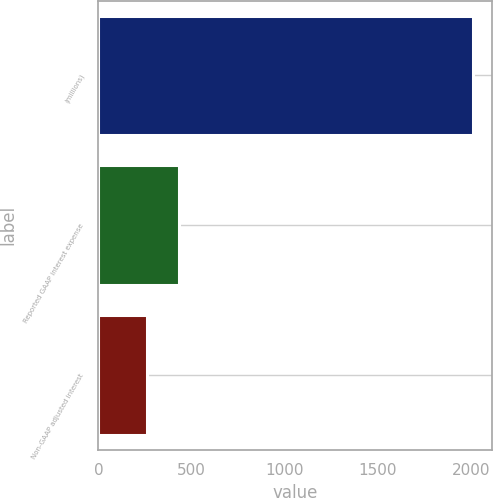Convert chart. <chart><loc_0><loc_0><loc_500><loc_500><bar_chart><fcel>(millions)<fcel>Reported GAAP interest expense<fcel>Non-GAAP adjusted interest<nl><fcel>2013<fcel>435.12<fcel>259.8<nl></chart> 